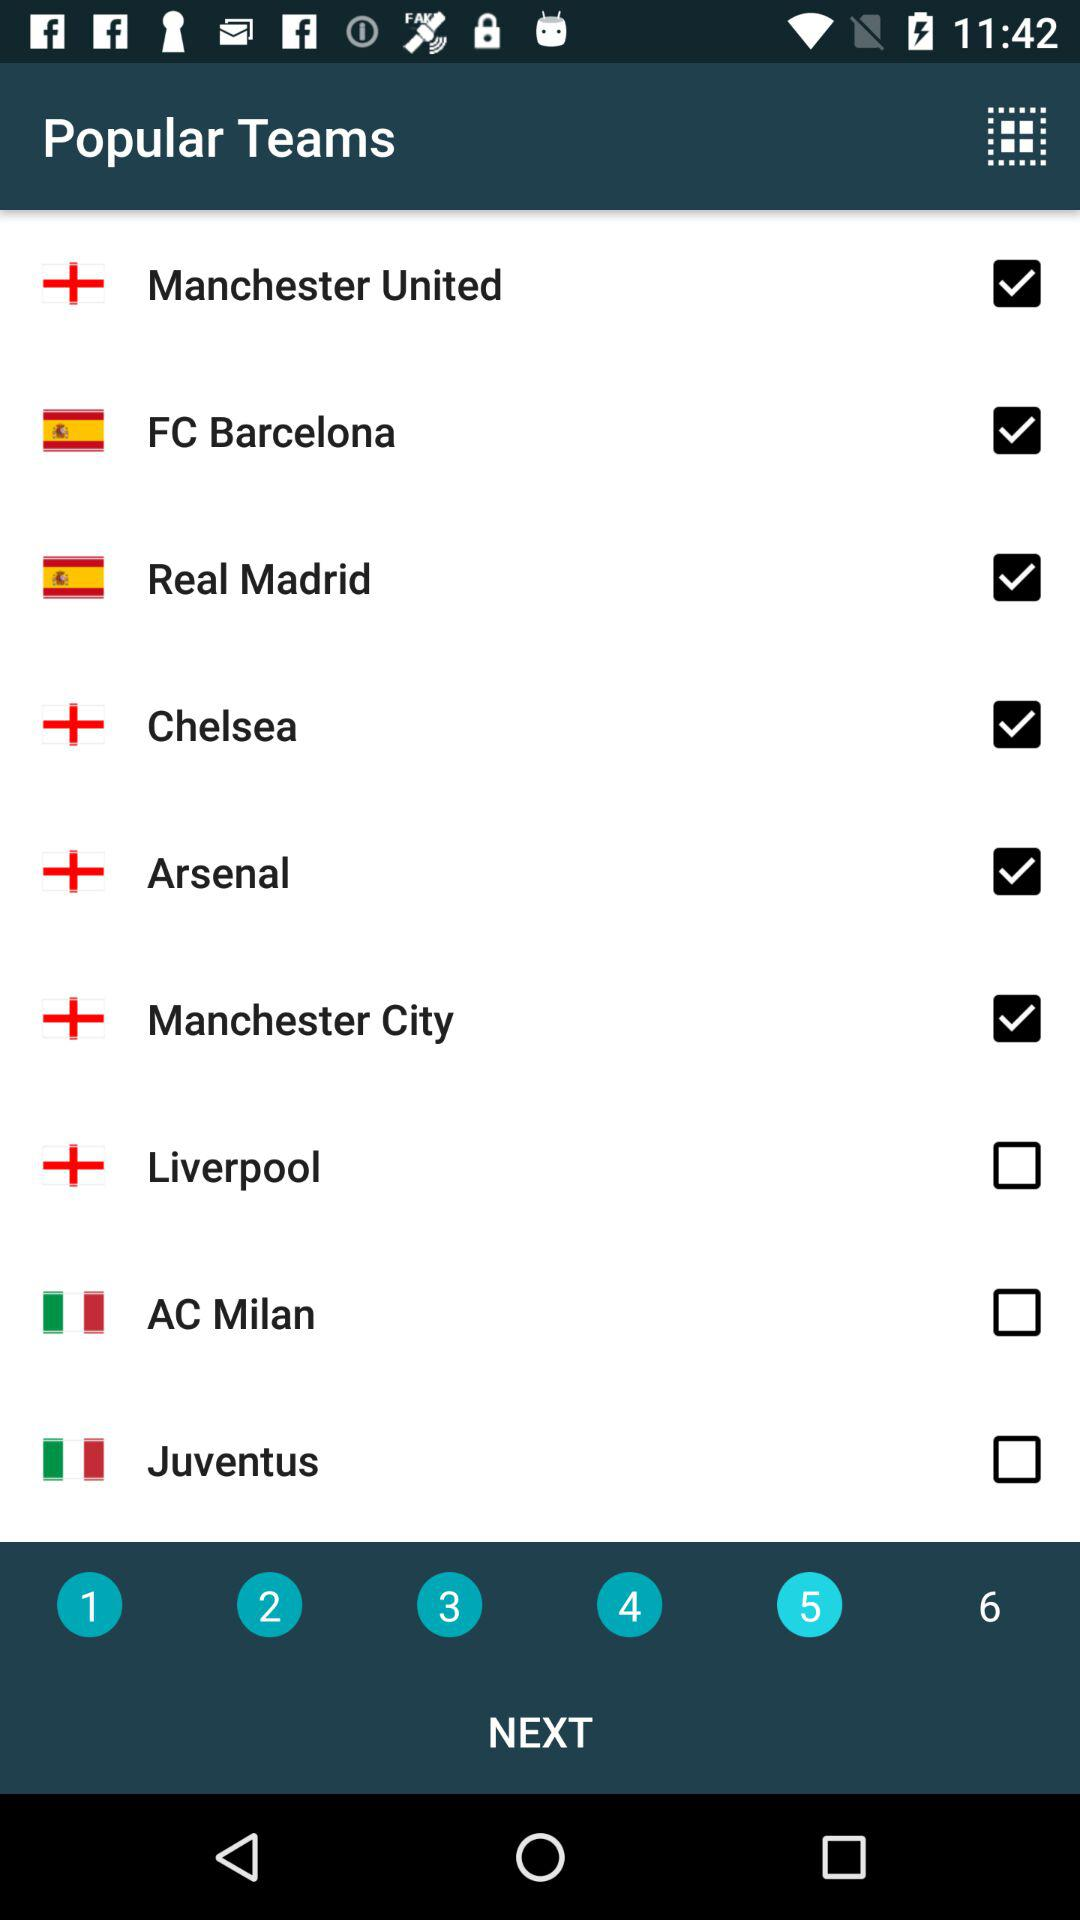Which of the following teams are not selected? The unselected teams are "Liverpool", "AC Milan" and "Juventus". 